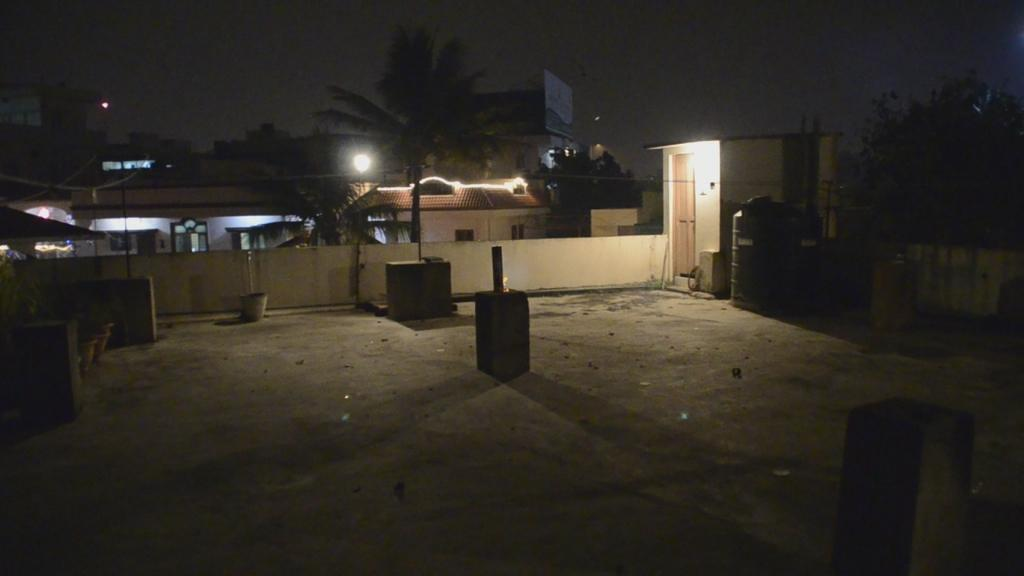What type of location is depicted in the image? The image is of a building's terrace. What architectural features can be seen on the terrace? There are pillars on the terrace. What objects are present on the terrace? There is a plant pot and a plastic tank on the terrace. Where is the entrance to the terrace located? There is a door at the right back of the terrace. What can be seen in the background of the image? Trees, buildings, and light are visible in the background. What color ink is being used to write on the suit in the image? There is no suit or ink present in the image; it features a building's terrace with pillars, a plant pot, a plastic tank, and a door. How many horses are visible on the terrace in the image? There are no horses present in the image; it features a building's terrace with pillars, a plant pot, a plastic tank, and a door. 